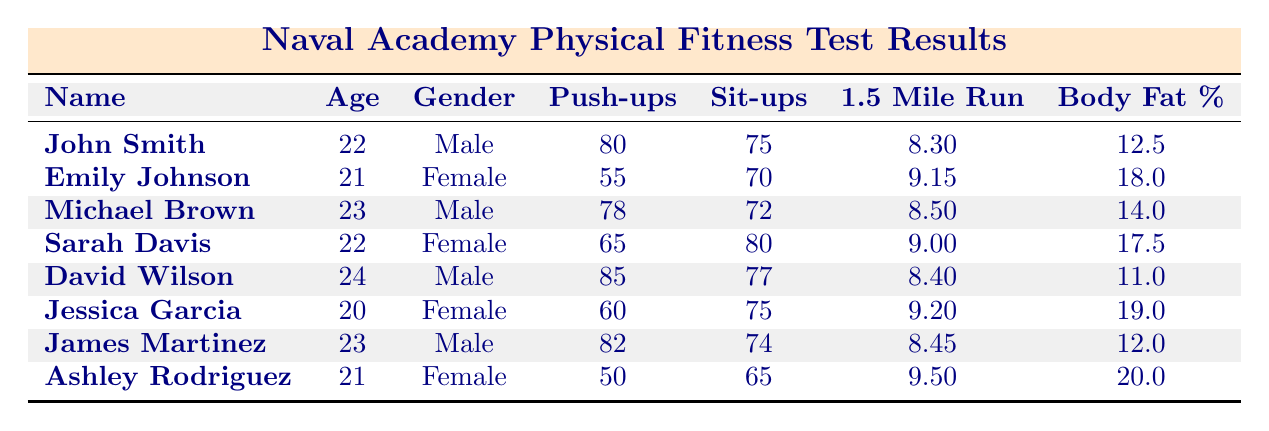What is the highest number of push-ups recorded? The push-up numbers listed in the table are 80, 55, 78, 65, 85, 60, 82, and 50. The maximum among these is 85, which belongs to David Wilson.
Answer: 85 Which female student has the lowest run time for the 1.5-mile run? The run times for female students are 9.15, 9.00, and 9.20. Among these, Sarah Davis has the lowest at 9.00.
Answer: 9.00 Is Emily Johnson older than Jessica Garcia? Emily Johnson is 21 years old, while Jessica Garcia is 20 years old. Since 21 is greater than 20, Emily is indeed older.
Answer: Yes What is the average body fat percentage for male students? The body fat percentages for male students are 12.5, 14.0, 11.0, and 12.0. The sum is 12.5 + 14.0 + 11.0 + 12.0 = 49.5, and there are 4 males, so the average is 49.5 / 4 = 12.375.
Answer: 12.375 Which student has the highest sit-up score? The sit-up scores listed are 75, 70, 72, 80, 77, 75, 74, and 65. The highest score is 80, which is achieved by Sarah Davis.
Answer: 80 What is the difference in push-up scores between David Wilson and Ashley Rodriguez? David Wilson's score is 85 and Ashley Rodriguez's is 50. To find the difference, subtract 50 from 85, which equals 35.
Answer: 35 Are there more male students with lower body fat percentages than female students? The male students have body fat percentages of 12.5, 14.0, 11.0, and 12.0, and the female students have 18.0, 17.5, 19.0, and 20.0. The males have 4 entries below 15, while the females have none, indicating more males have lower percentages.
Answer: Yes What is the median push-up score among the students? After sorting the push-up scores: 50, 55, 60, 65, 78, 80, 82, 85, the middle scores are 78 and 80. To find the median, average these two values: (78 + 80) / 2 = 79.
Answer: 79 